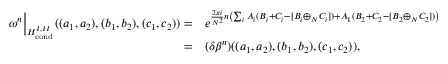Convert formula to latex. <formula><loc_0><loc_0><loc_500><loc_500>\begin{array} { r l } { \omega ^ { n } \Big | _ { H _ { c o n d } ^ { I , I I } } ( ( a _ { 1 } , a _ { 2 } ) , ( b _ { 1 } , b _ { 2 } ) , ( c _ { 1 } , c _ { 2 } ) ) = } & { e ^ { \frac { 2 \pi i } { N ^ { 2 } } n \left ( \sum _ { i } A _ { i } ( B _ { i } + C _ { i } - [ B _ { i } \oplus _ { N } C _ { i } ] ) + A _ { 1 } ( B _ { 2 } + C _ { 2 } - [ B _ { 2 } \oplus _ { N } C _ { 2 } ] ) \right ) } } \\ { = } & { ( \delta \beta ^ { n } ) ( ( a _ { 1 } , a _ { 2 } ) , ( b _ { 1 } , b _ { 2 } ) , ( c _ { 1 } , c _ { 2 } ) ) , } \end{array}</formula> 